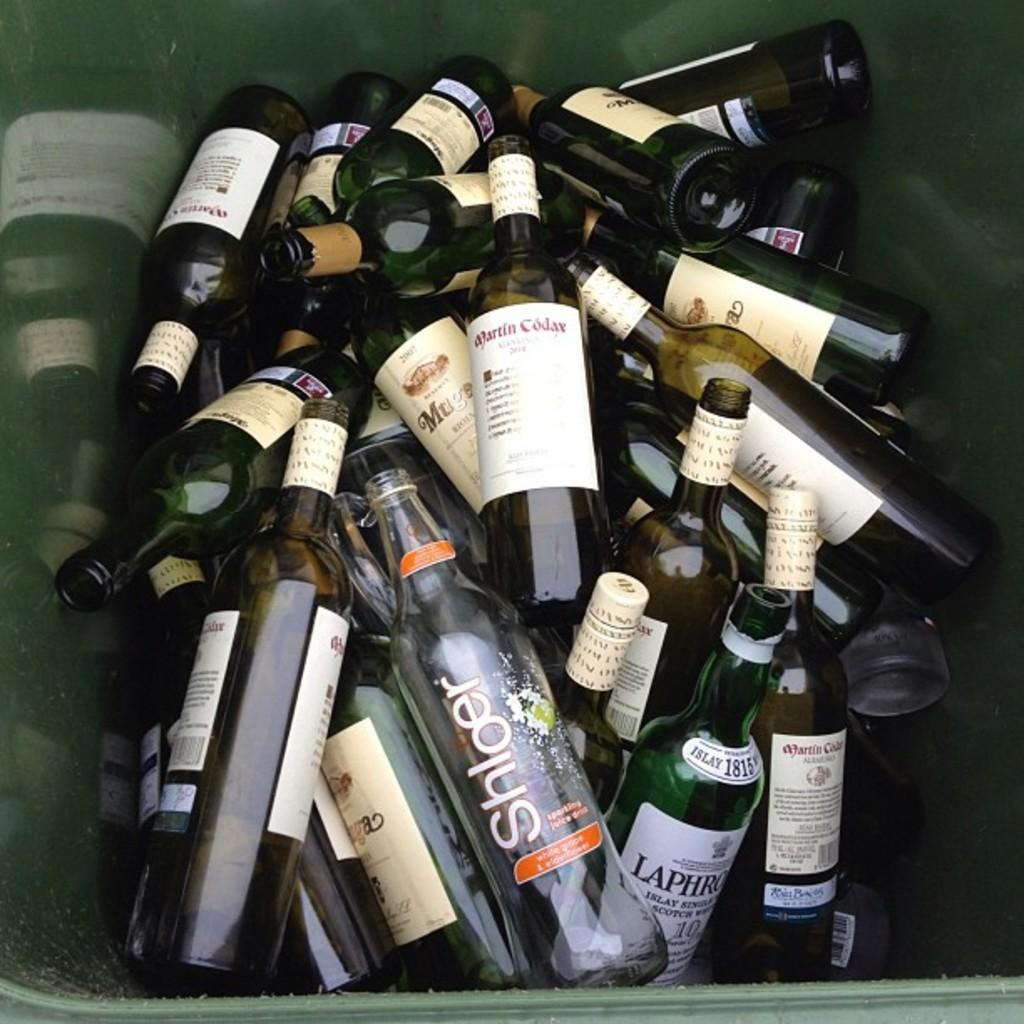What is inside the container in the image? There is a group of bottles in a container. What can be seen on the bottles? The bottles have stickers on them. What type of stomach is visible in the image? There is no stomach visible in the image; it features a group of bottles with stickers on them. 